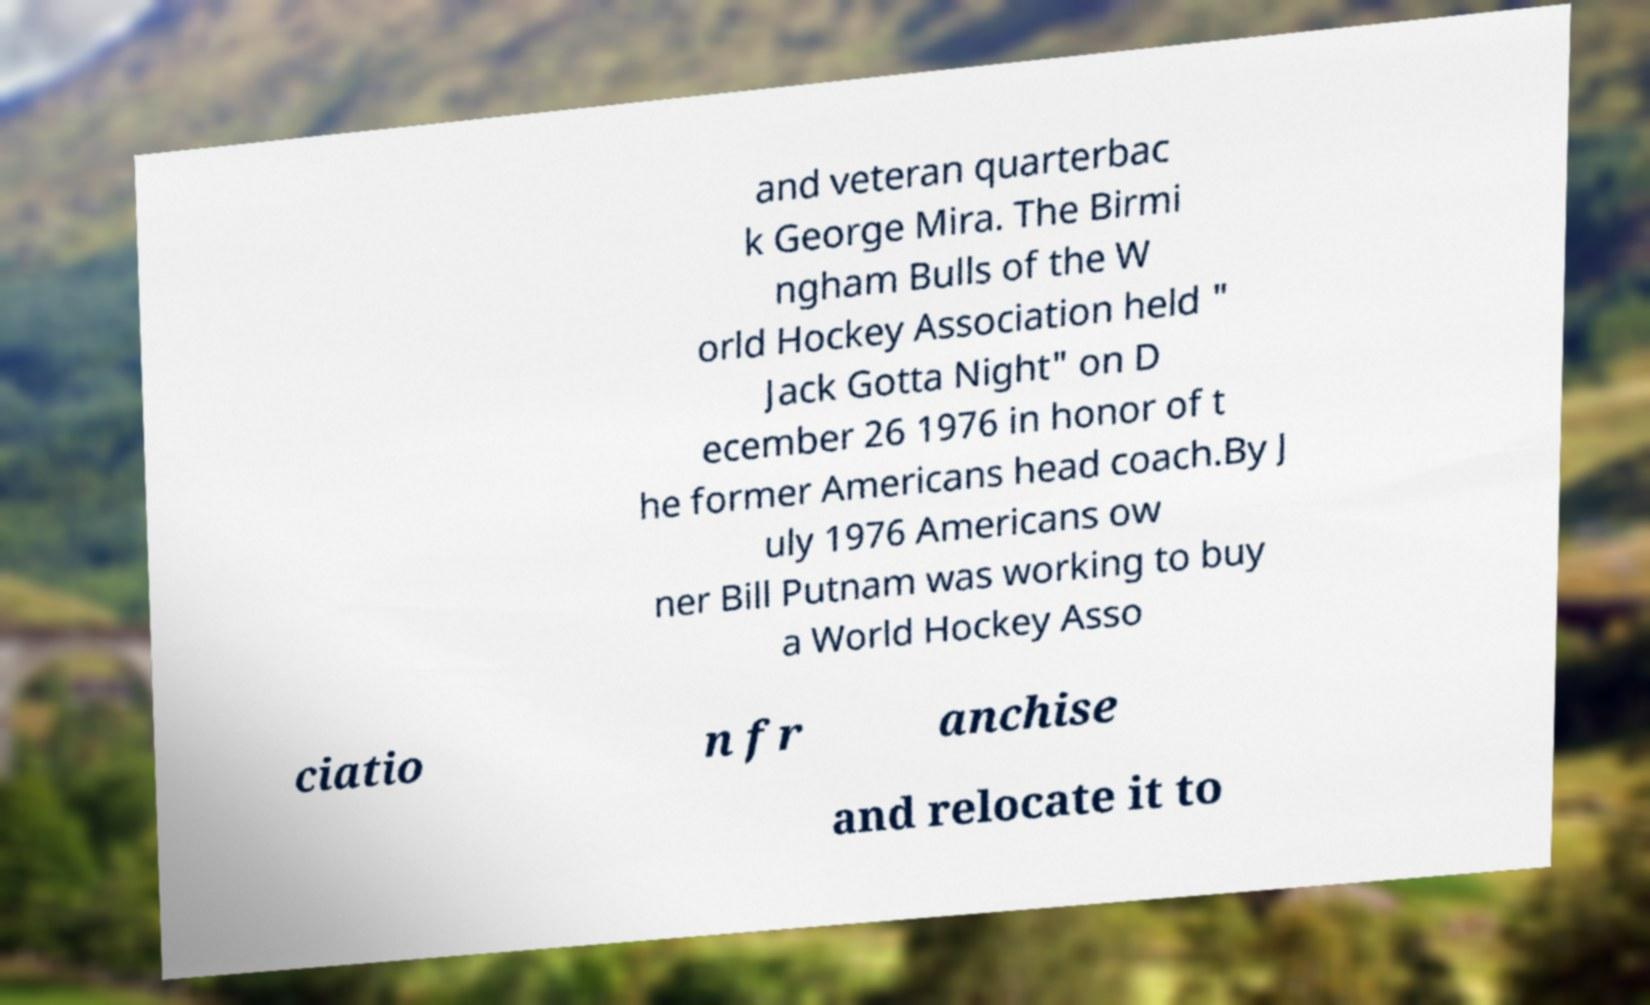Could you extract and type out the text from this image? and veteran quarterbac k George Mira. The Birmi ngham Bulls of the W orld Hockey Association held " Jack Gotta Night" on D ecember 26 1976 in honor of t he former Americans head coach.By J uly 1976 Americans ow ner Bill Putnam was working to buy a World Hockey Asso ciatio n fr anchise and relocate it to 